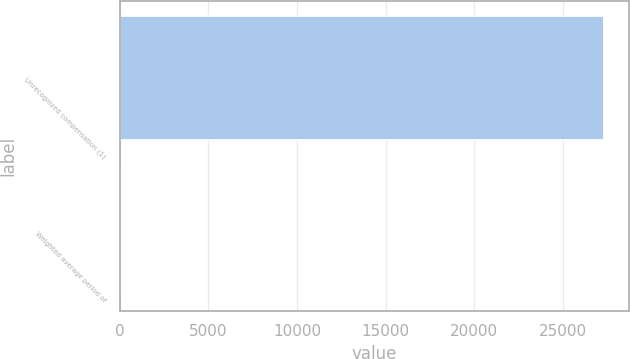<chart> <loc_0><loc_0><loc_500><loc_500><bar_chart><fcel>Unrecognized compensation (1)<fcel>Weighted average period of<nl><fcel>27334<fcel>0.89<nl></chart> 